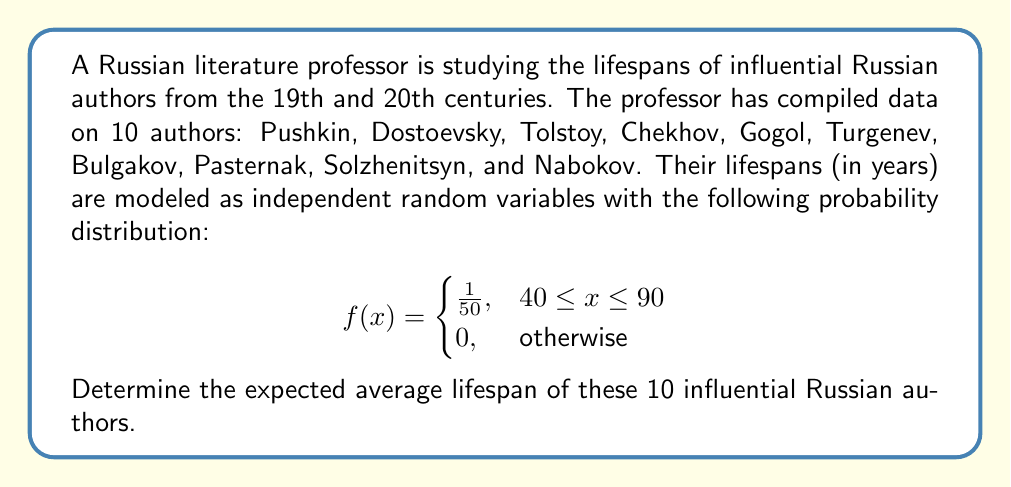Could you help me with this problem? Let's approach this step-by-step:

1) First, we need to find the expected value (mean) of the lifespan for a single author. Given the probability density function:

   $$E[X] = \int_{40}^{90} x \cdot \frac{1}{50} dx$$

2) Solving this integral:

   $$E[X] = \frac{1}{50} \left[ \frac{x^2}{2} \right]_{40}^{90} = \frac{1}{50} \left( \frac{90^2}{2} - \frac{40^2}{2} \right) = \frac{8100 - 1600}{100} = 65$$

3) So the expected lifespan for a single author is 65 years.

4) Now, let $Y$ be the average lifespan of the 10 authors. We can express this as:

   $$Y = \frac{X_1 + X_2 + ... + X_{10}}{10}$$

   where each $X_i$ represents the lifespan of an individual author.

5) The expected value of Y is:

   $$E[Y] = E\left[\frac{X_1 + X_2 + ... + X_{10}}{10}\right]$$

6) Due to the linearity of expectation:

   $$E[Y] = \frac{E[X_1] + E[X_2] + ... + E[X_{10}]}{10}$$

7) Since all $X_i$ have the same distribution, their expected values are all equal to 65:

   $$E[Y] = \frac{65 + 65 + ... + 65}{10} = \frac{65 \cdot 10}{10} = 65$$

Therefore, the expected average lifespan of these 10 influential Russian authors is 65 years.
Answer: 65 years 